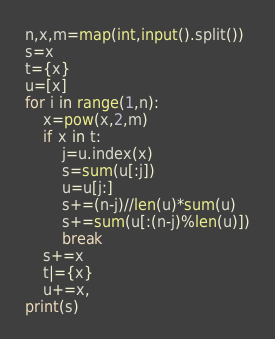<code> <loc_0><loc_0><loc_500><loc_500><_Cython_>n,x,m=map(int,input().split())
s=x
t={x}
u=[x]
for i in range(1,n):
    x=pow(x,2,m)
    if x in t:
        j=u.index(x)
        s=sum(u[:j])
        u=u[j:]
        s+=(n-j)//len(u)*sum(u)
        s+=sum(u[:(n-j)%len(u)])
        break
    s+=x
    t|={x}
    u+=x,
print(s)</code> 